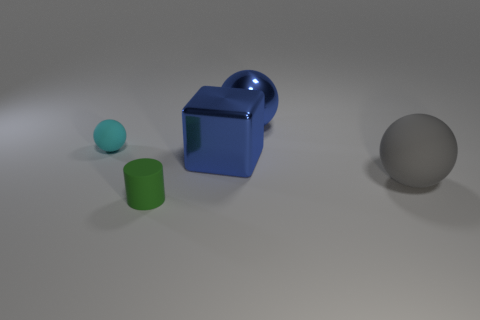Add 4 yellow metallic cylinders. How many objects exist? 9 Subtract all spheres. How many objects are left? 2 Add 3 blue cubes. How many blue cubes are left? 4 Add 5 small cylinders. How many small cylinders exist? 6 Subtract 0 purple cubes. How many objects are left? 5 Subtract all large green balls. Subtract all big metal objects. How many objects are left? 3 